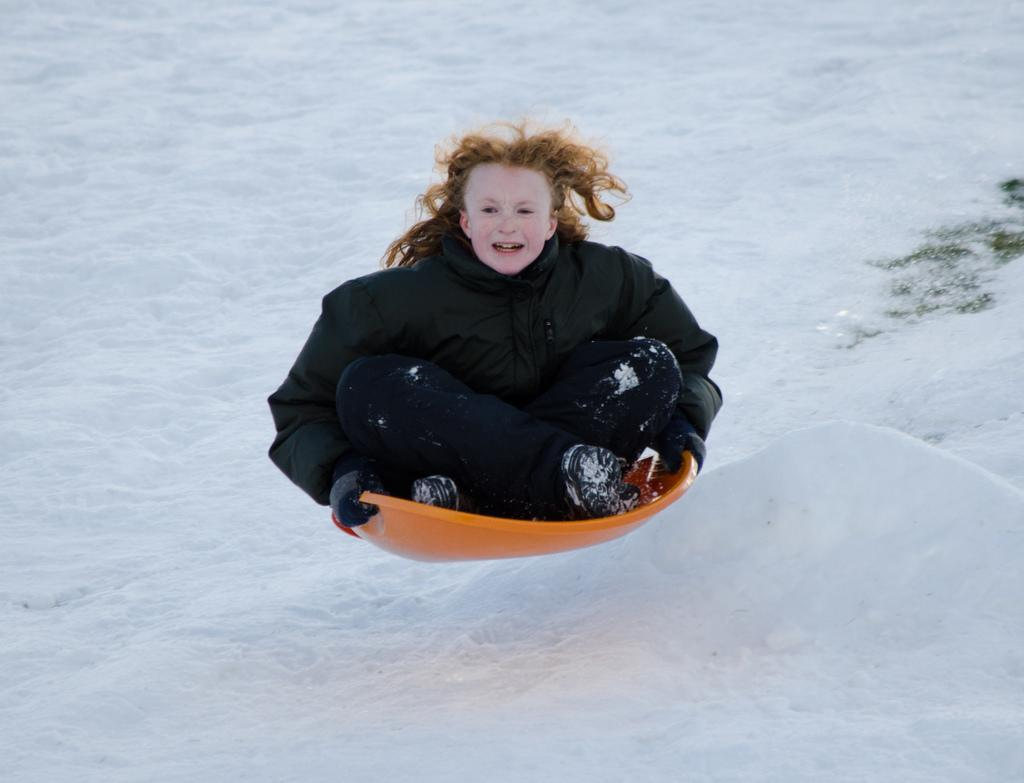Who is the main subject in the image? There is a girl in the image. What activity is the girl engaged in? The girl is tubing. What type of surface is the tubing taking place on? The tubing is taking place on snow. What color is the marble that the girl is holding in the image? There is no marble present in the image; the girl is tubing on snow. 